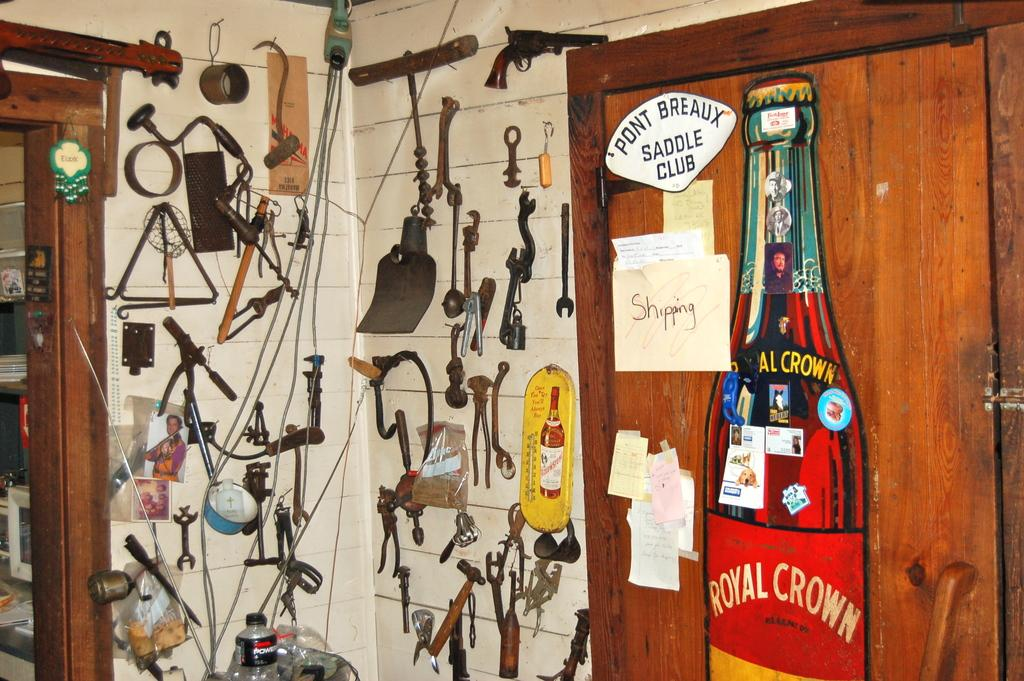<image>
Provide a brief description of the given image. A sign from the Pont Breaux Saddle Club hangs on a door along with other papers and signs. 